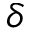Convert formula to latex. <formula><loc_0><loc_0><loc_500><loc_500>\delta</formula> 